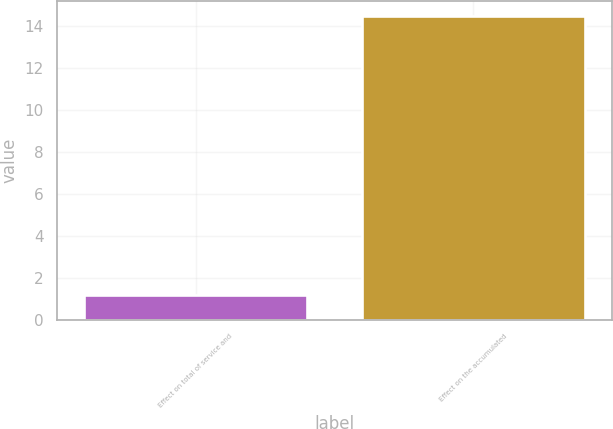Convert chart to OTSL. <chart><loc_0><loc_0><loc_500><loc_500><bar_chart><fcel>Effect on total of service and<fcel>Effect on the accumulated<nl><fcel>1.2<fcel>14.5<nl></chart> 